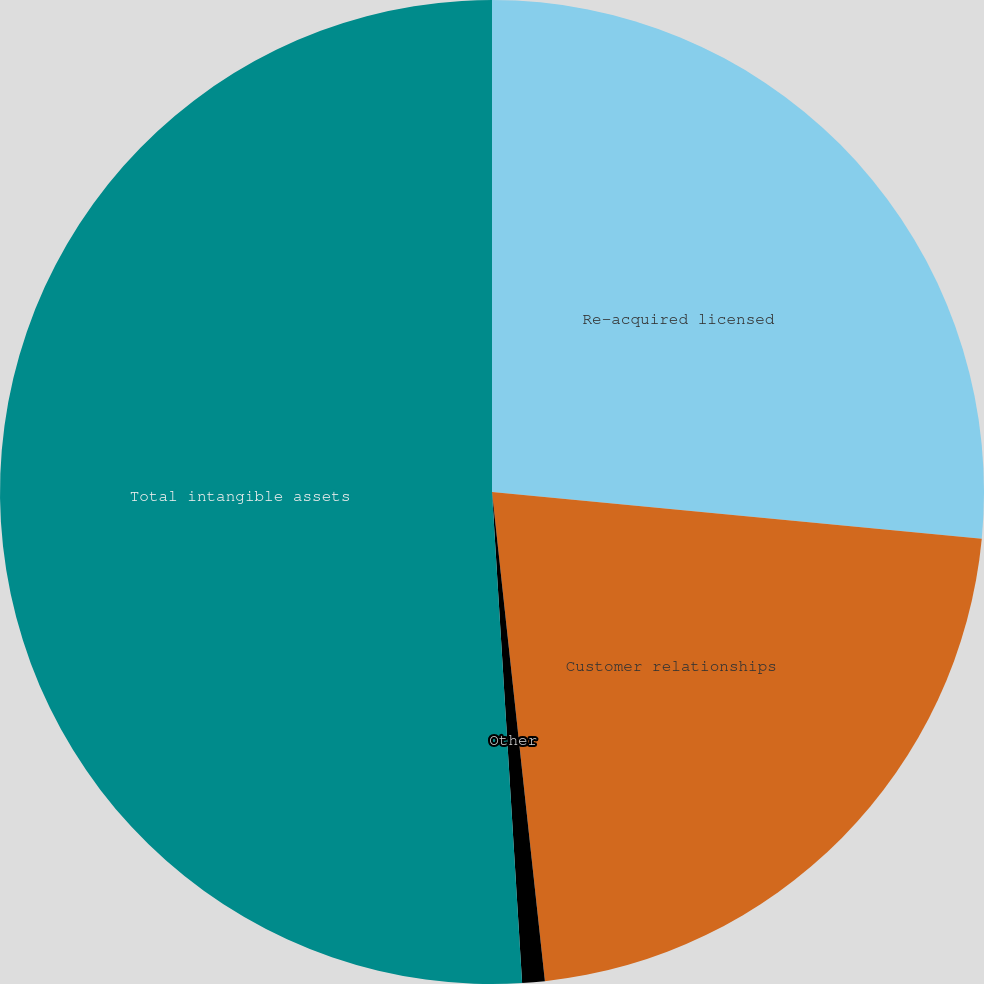<chart> <loc_0><loc_0><loc_500><loc_500><pie_chart><fcel>Re-acquired licensed<fcel>Customer relationships<fcel>Other<fcel>Total intangible assets<nl><fcel>26.51%<fcel>21.77%<fcel>0.74%<fcel>50.97%<nl></chart> 